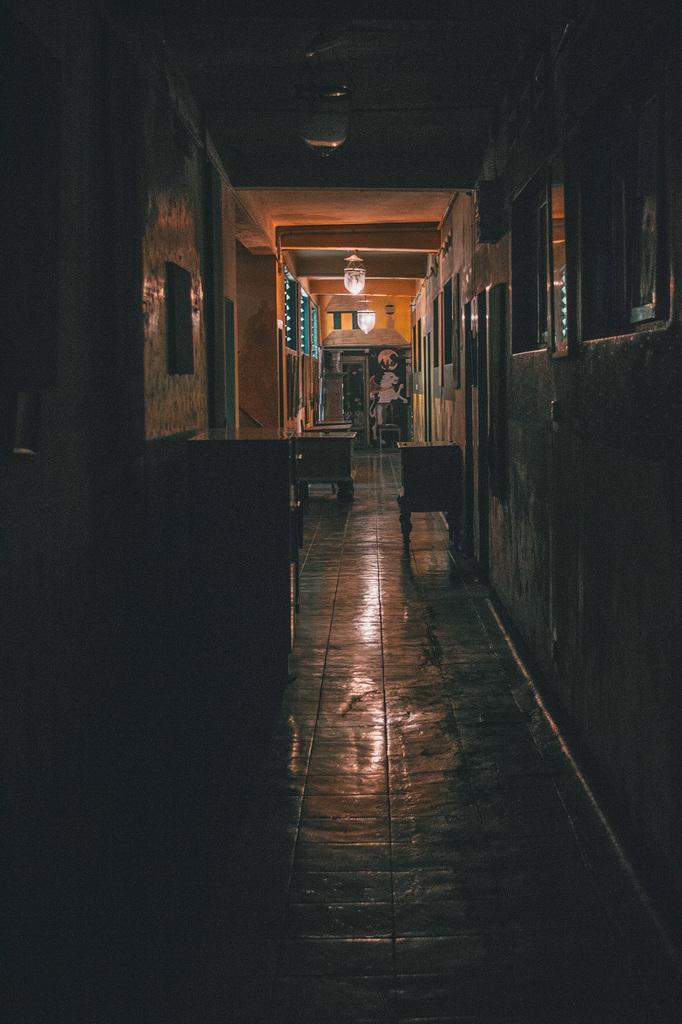Could you give a brief overview of what you see in this image? In this image we can see a corridor and there are stands. In the background there is a wall and we can see lights. We can see frames placed on the wall. 